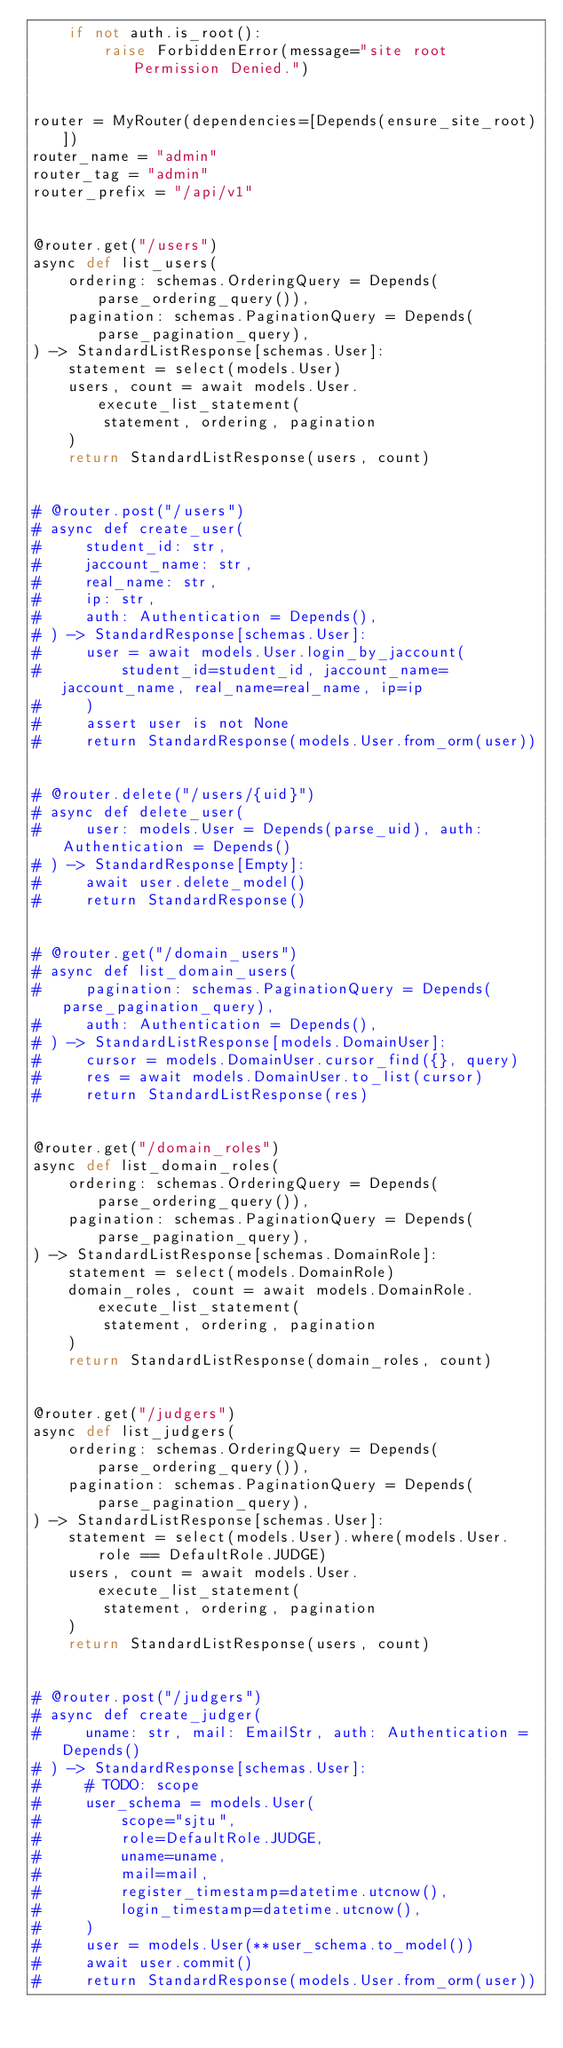<code> <loc_0><loc_0><loc_500><loc_500><_Python_>    if not auth.is_root():
        raise ForbiddenError(message="site root Permission Denied.")


router = MyRouter(dependencies=[Depends(ensure_site_root)])
router_name = "admin"
router_tag = "admin"
router_prefix = "/api/v1"


@router.get("/users")
async def list_users(
    ordering: schemas.OrderingQuery = Depends(parse_ordering_query()),
    pagination: schemas.PaginationQuery = Depends(parse_pagination_query),
) -> StandardListResponse[schemas.User]:
    statement = select(models.User)
    users, count = await models.User.execute_list_statement(
        statement, ordering, pagination
    )
    return StandardListResponse(users, count)


# @router.post("/users")
# async def create_user(
#     student_id: str,
#     jaccount_name: str,
#     real_name: str,
#     ip: str,
#     auth: Authentication = Depends(),
# ) -> StandardResponse[schemas.User]:
#     user = await models.User.login_by_jaccount(
#         student_id=student_id, jaccount_name=jaccount_name, real_name=real_name, ip=ip
#     )
#     assert user is not None
#     return StandardResponse(models.User.from_orm(user))


# @router.delete("/users/{uid}")
# async def delete_user(
#     user: models.User = Depends(parse_uid), auth: Authentication = Depends()
# ) -> StandardResponse[Empty]:
#     await user.delete_model()
#     return StandardResponse()


# @router.get("/domain_users")
# async def list_domain_users(
#     pagination: schemas.PaginationQuery = Depends(parse_pagination_query),
#     auth: Authentication = Depends(),
# ) -> StandardListResponse[models.DomainUser]:
#     cursor = models.DomainUser.cursor_find({}, query)
#     res = await models.DomainUser.to_list(cursor)
#     return StandardListResponse(res)


@router.get("/domain_roles")
async def list_domain_roles(
    ordering: schemas.OrderingQuery = Depends(parse_ordering_query()),
    pagination: schemas.PaginationQuery = Depends(parse_pagination_query),
) -> StandardListResponse[schemas.DomainRole]:
    statement = select(models.DomainRole)
    domain_roles, count = await models.DomainRole.execute_list_statement(
        statement, ordering, pagination
    )
    return StandardListResponse(domain_roles, count)


@router.get("/judgers")
async def list_judgers(
    ordering: schemas.OrderingQuery = Depends(parse_ordering_query()),
    pagination: schemas.PaginationQuery = Depends(parse_pagination_query),
) -> StandardListResponse[schemas.User]:
    statement = select(models.User).where(models.User.role == DefaultRole.JUDGE)
    users, count = await models.User.execute_list_statement(
        statement, ordering, pagination
    )
    return StandardListResponse(users, count)


# @router.post("/judgers")
# async def create_judger(
#     uname: str, mail: EmailStr, auth: Authentication = Depends()
# ) -> StandardResponse[schemas.User]:
#     # TODO: scope
#     user_schema = models.User(
#         scope="sjtu",
#         role=DefaultRole.JUDGE,
#         uname=uname,
#         mail=mail,
#         register_timestamp=datetime.utcnow(),
#         login_timestamp=datetime.utcnow(),
#     )
#     user = models.User(**user_schema.to_model())
#     await user.commit()
#     return StandardResponse(models.User.from_orm(user))
</code> 